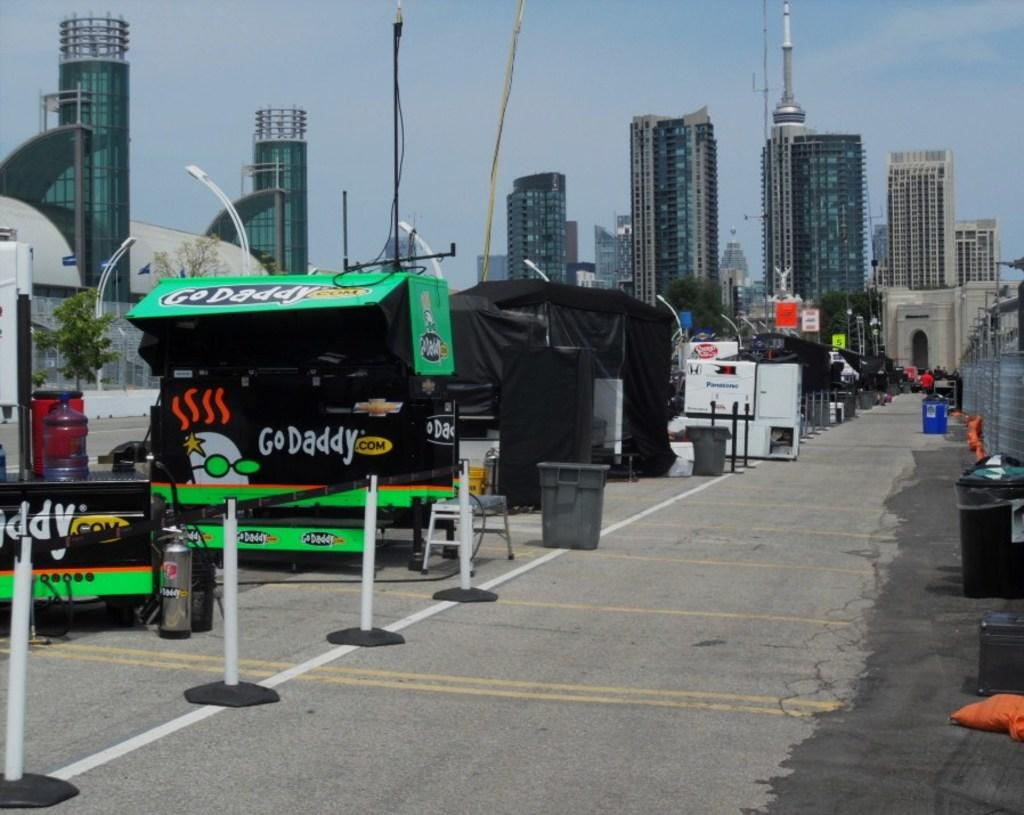What can be seen on the objects in the image? There are objects with writing on them in the image. What are the objects with writing on them used for? It is not clear from the image what the objects with writing are used for. What can be found beside the objects with writing? There are dustbins beside the objects in the image. What is visible in the background of the image? There are buildings in the background of the image. Are there any horses visible in the image? No, there are no horses present in the image. What is the quickest way to reach the buildings in the background? The image does not provide enough information to determine the quickest way to reach the buildings in the background. 